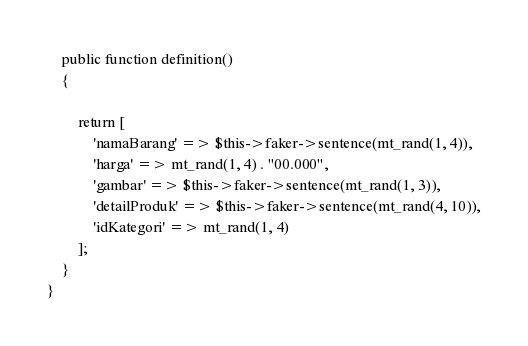Convert code to text. <code><loc_0><loc_0><loc_500><loc_500><_PHP_>    public function definition()
    {

        return [
            'namaBarang' => $this->faker->sentence(mt_rand(1, 4)),
            'harga' => mt_rand(1, 4) . "00.000",
            'gambar' => $this->faker->sentence(mt_rand(1, 3)),
            'detailProduk' => $this->faker->sentence(mt_rand(4, 10)),
            'idKategori' => mt_rand(1, 4)
        ];
    }
}
</code> 